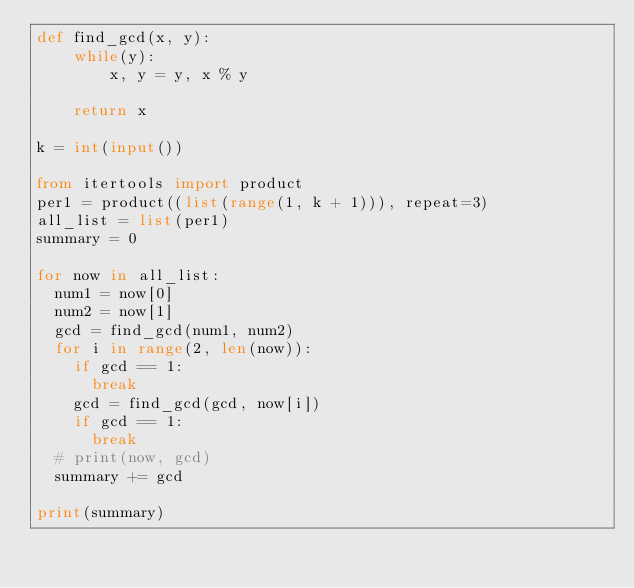<code> <loc_0><loc_0><loc_500><loc_500><_Python_>def find_gcd(x, y): 
    while(y): 
        x, y = y, x % y 
  
    return x 

k = int(input())

from itertools import product
per1 = product((list(range(1, k + 1))), repeat=3)
all_list = list(per1)
summary = 0

for now in all_list:
  num1 = now[0]
  num2 = now[1]
  gcd = find_gcd(num1, num2)
  for i in range(2, len(now)):
    if gcd == 1:
      break
    gcd = find_gcd(gcd, now[i])
    if gcd == 1:
      break
  # print(now, gcd)
  summary += gcd

print(summary)</code> 